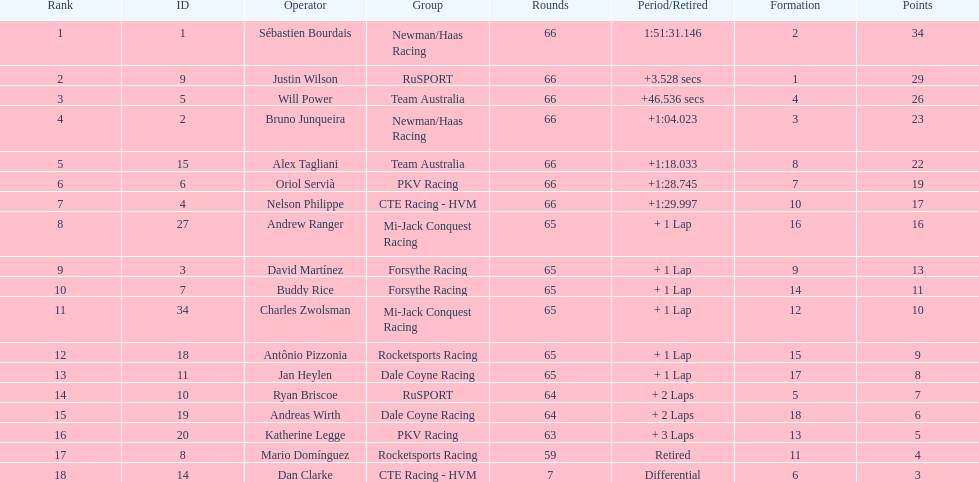What is the number of laps dan clarke completed? 7. 